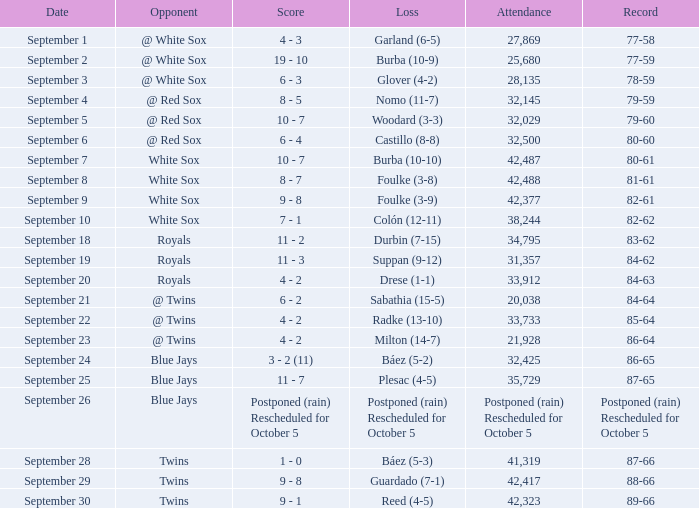What is the score of the game that holds a record of 80-61? 10 - 7. 